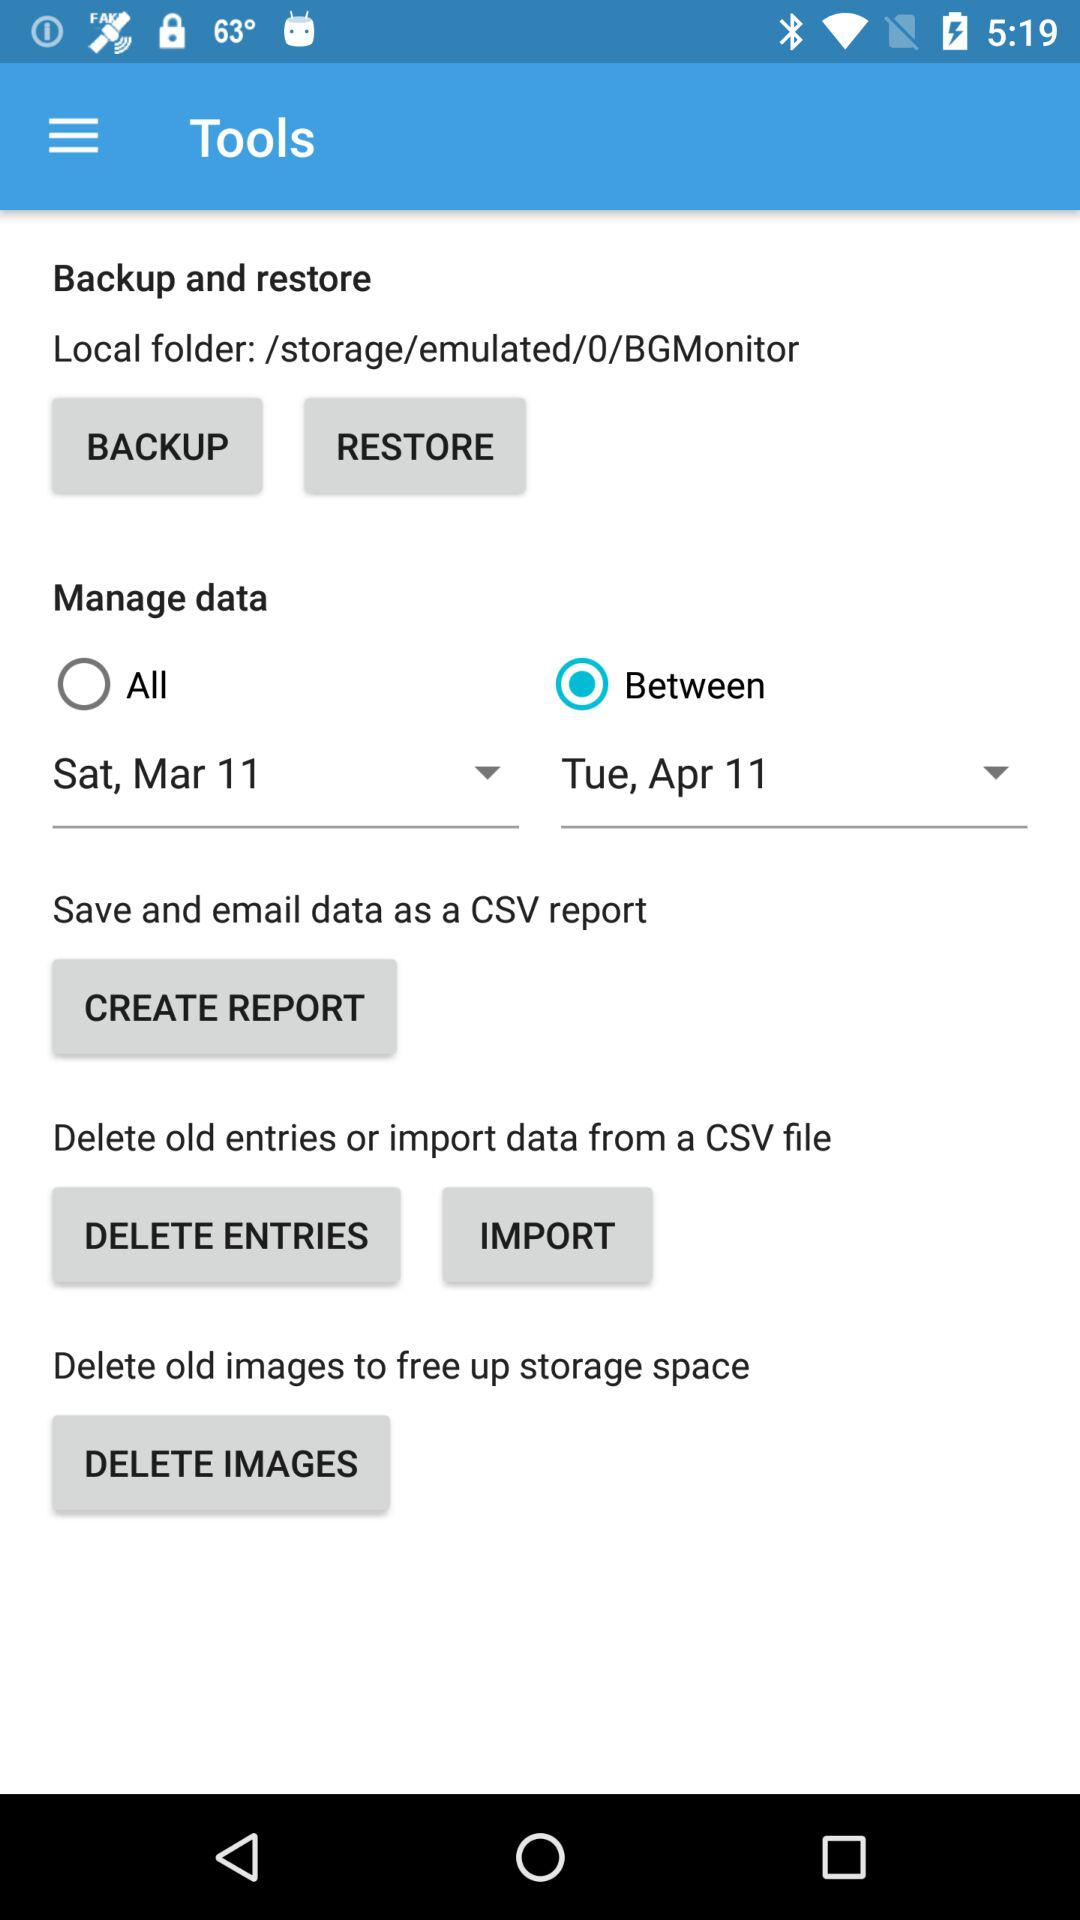Between what dates can the data be managed? Data can be managed between Saturday, March 11 and Tuesday, April 11. 